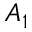<formula> <loc_0><loc_0><loc_500><loc_500>A _ { 1 }</formula> 